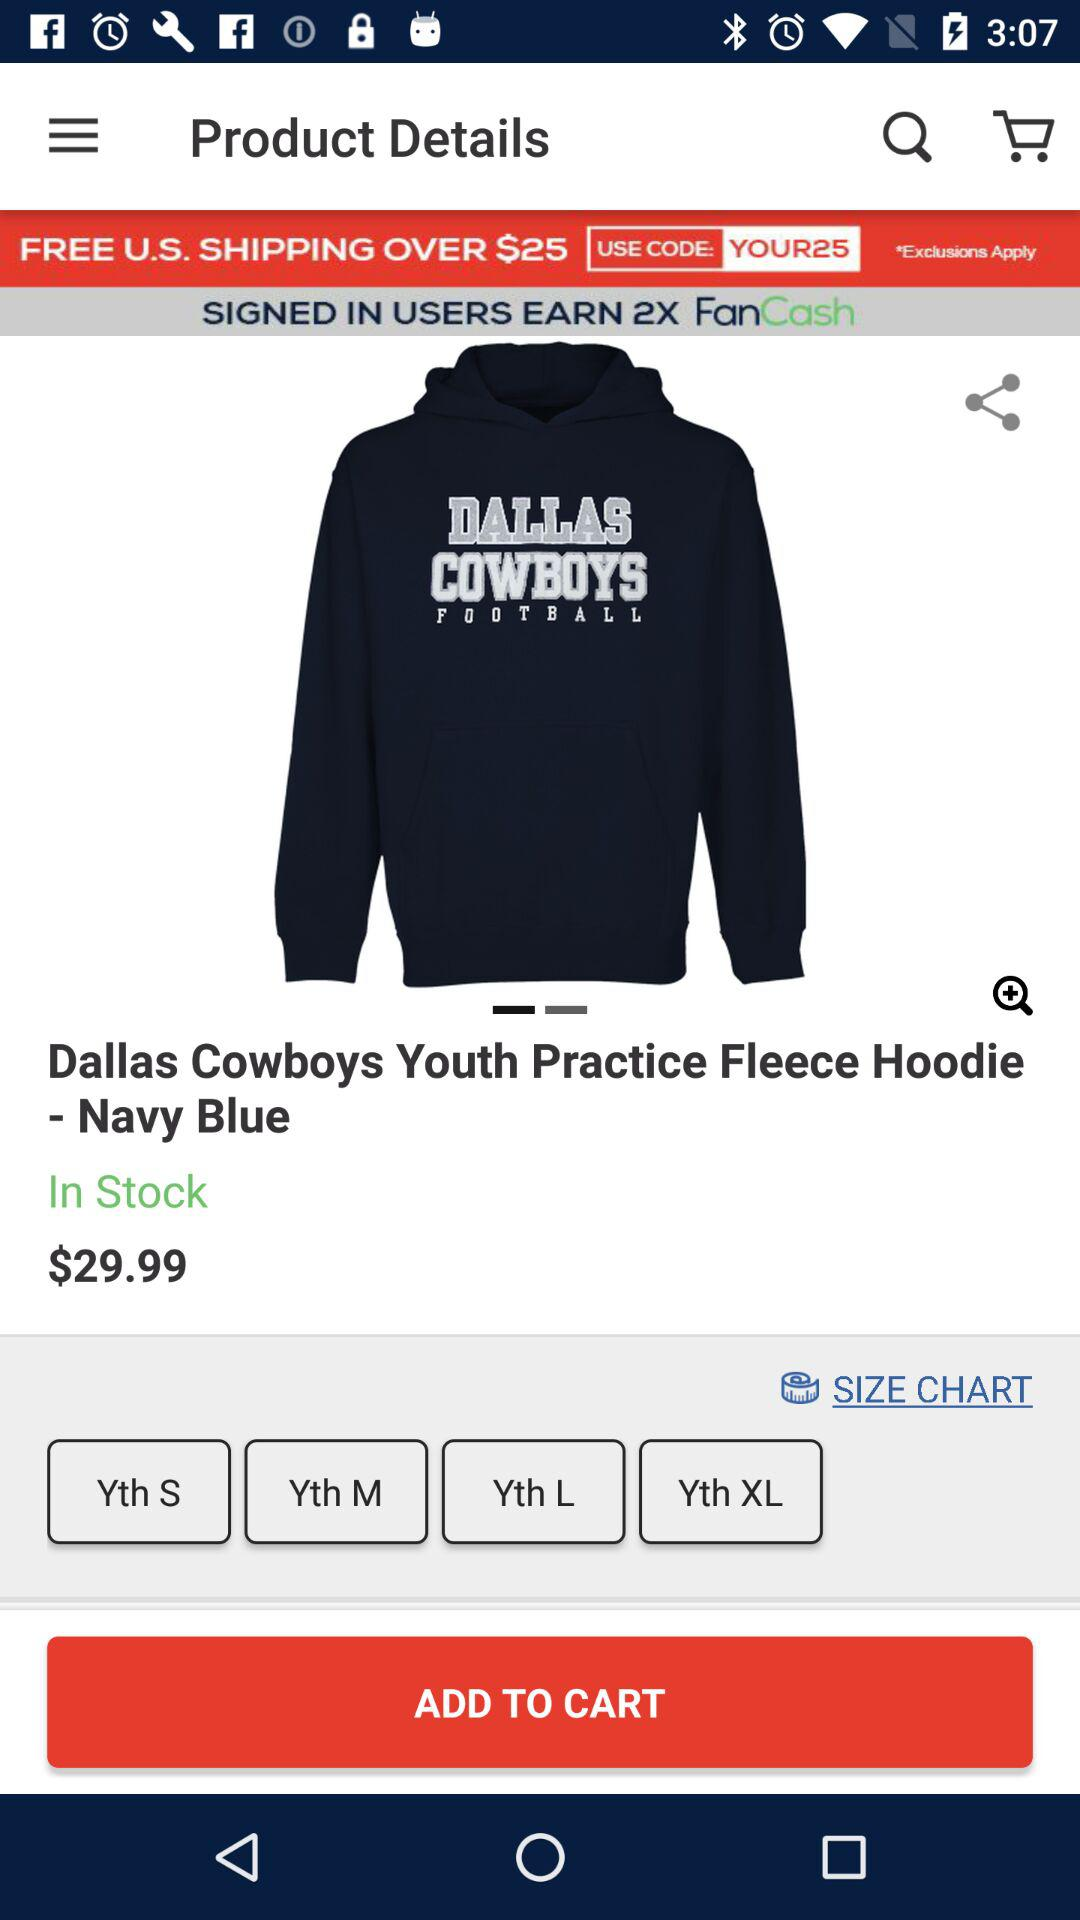How much is the hoodie before the discount is applied?
Answer the question using a single word or phrase. $29.99 